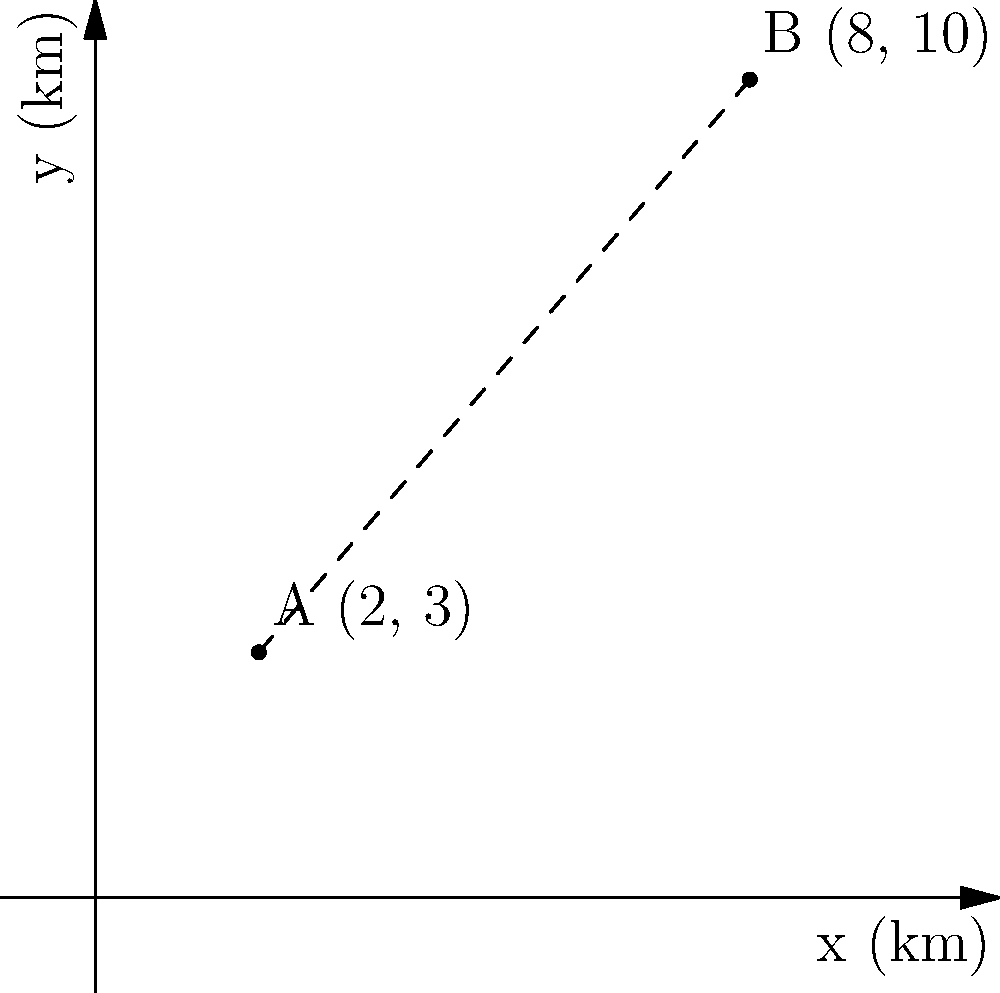As you prepare for your move to Tokyo, you're researching potential schools for your child. You've identified two highly-rated international schools: School A located at coordinates (2, 3) and School B at (8, 10), where the coordinates represent distances in kilometers from the city center. Calculate the straight-line distance between these two schools to help plan your daily commute and school visits. To find the distance between two points in a coordinate plane, we can use the distance formula:

$$ d = \sqrt{(x_2 - x_1)^2 + (y_2 - y_1)^2} $$

Where $(x_1, y_1)$ are the coordinates of the first point and $(x_2, y_2)$ are the coordinates of the second point.

Given:
- School A: $(x_1, y_1) = (2, 3)$
- School B: $(x_2, y_2) = (8, 10)$

Let's substitute these values into the formula:

$$ d = \sqrt{(8 - 2)^2 + (10 - 3)^2} $$

Simplify inside the parentheses:
$$ d = \sqrt{6^2 + 7^2} $$

Calculate the squares:
$$ d = \sqrt{36 + 49} $$

Add inside the square root:
$$ d = \sqrt{85} $$

The square root of 85 is approximately 9.22 km.
Answer: 9.22 km 